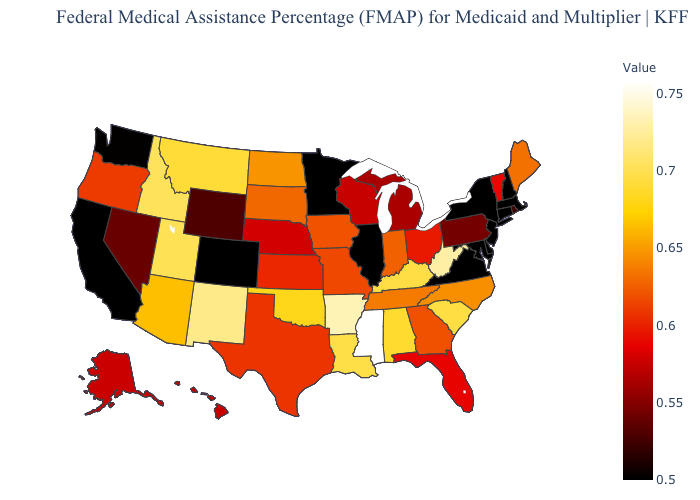Among the states that border Idaho , which have the lowest value?
Concise answer only. Washington. Which states have the highest value in the USA?
Short answer required. Mississippi. Among the states that border Oklahoma , does Kansas have the highest value?
Write a very short answer. No. Does Wisconsin have a lower value than Washington?
Answer briefly. No. 